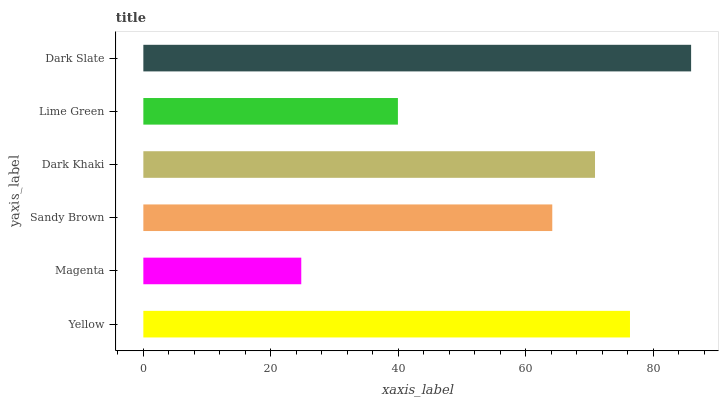Is Magenta the minimum?
Answer yes or no. Yes. Is Dark Slate the maximum?
Answer yes or no. Yes. Is Sandy Brown the minimum?
Answer yes or no. No. Is Sandy Brown the maximum?
Answer yes or no. No. Is Sandy Brown greater than Magenta?
Answer yes or no. Yes. Is Magenta less than Sandy Brown?
Answer yes or no. Yes. Is Magenta greater than Sandy Brown?
Answer yes or no. No. Is Sandy Brown less than Magenta?
Answer yes or no. No. Is Dark Khaki the high median?
Answer yes or no. Yes. Is Sandy Brown the low median?
Answer yes or no. Yes. Is Lime Green the high median?
Answer yes or no. No. Is Dark Khaki the low median?
Answer yes or no. No. 